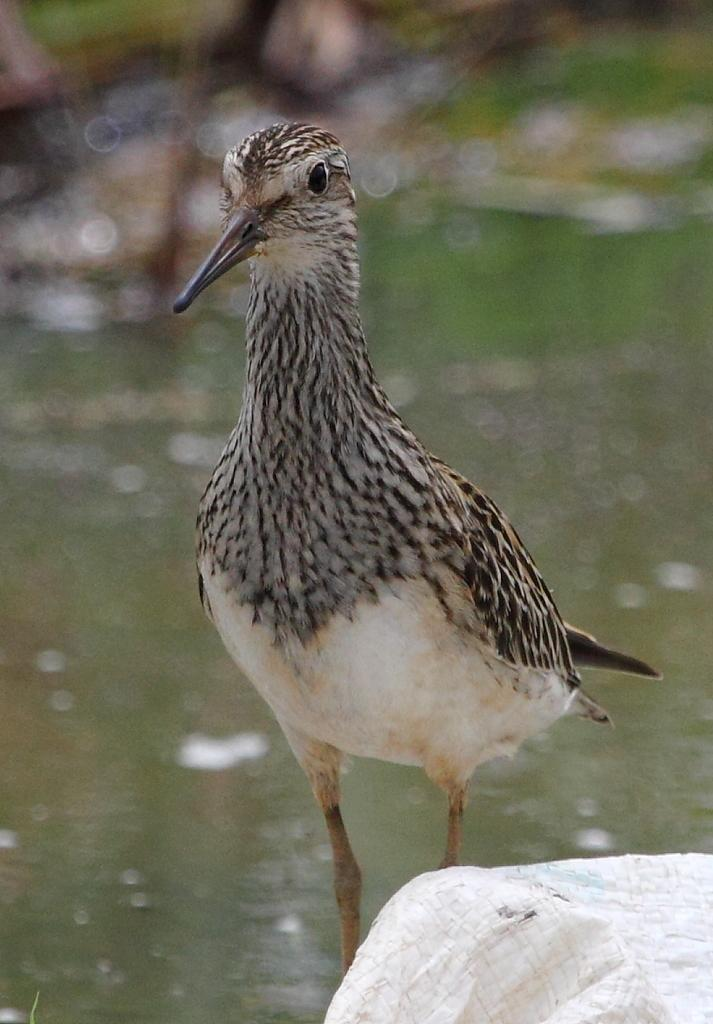What type of animal can be seen in the image? There is a bird in the image. Can you describe the background of the image? The background of the image is blurry. What is visible at the bottom of the image? There is water visible at the bottom of the image. What is located in the foreground of the image? There is a cloth in the foreground of the image. Can you tell me how many bars of soap are on the bird's wings in the image? There are no bars of soap present in the image, and the bird's wings are not mentioned in the provided facts. 